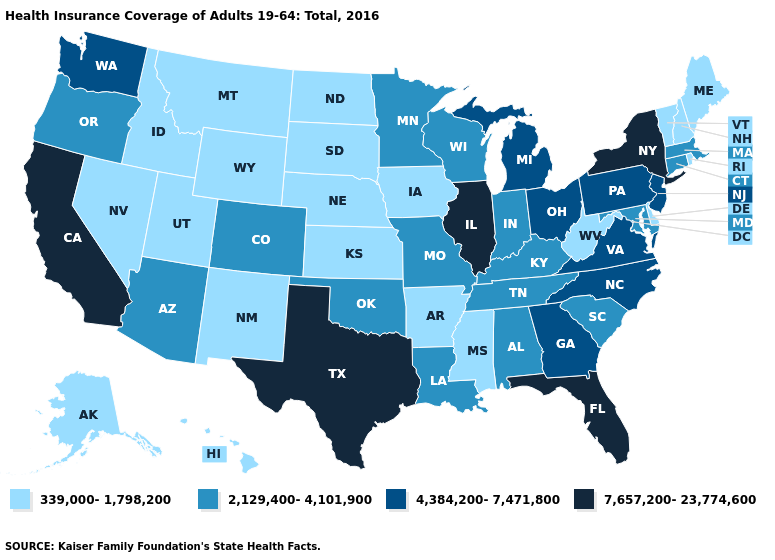Does Alabama have the same value as New Hampshire?
Be succinct. No. Name the states that have a value in the range 7,657,200-23,774,600?
Keep it brief. California, Florida, Illinois, New York, Texas. Name the states that have a value in the range 2,129,400-4,101,900?
Be succinct. Alabama, Arizona, Colorado, Connecticut, Indiana, Kentucky, Louisiana, Maryland, Massachusetts, Minnesota, Missouri, Oklahoma, Oregon, South Carolina, Tennessee, Wisconsin. What is the value of Illinois?
Answer briefly. 7,657,200-23,774,600. Does California have the same value as Texas?
Write a very short answer. Yes. Which states have the highest value in the USA?
Answer briefly. California, Florida, Illinois, New York, Texas. What is the value of Virginia?
Be succinct. 4,384,200-7,471,800. Does the first symbol in the legend represent the smallest category?
Give a very brief answer. Yes. What is the value of Maryland?
Give a very brief answer. 2,129,400-4,101,900. Which states have the lowest value in the USA?
Write a very short answer. Alaska, Arkansas, Delaware, Hawaii, Idaho, Iowa, Kansas, Maine, Mississippi, Montana, Nebraska, Nevada, New Hampshire, New Mexico, North Dakota, Rhode Island, South Dakota, Utah, Vermont, West Virginia, Wyoming. Does the map have missing data?
Concise answer only. No. Name the states that have a value in the range 2,129,400-4,101,900?
Keep it brief. Alabama, Arizona, Colorado, Connecticut, Indiana, Kentucky, Louisiana, Maryland, Massachusetts, Minnesota, Missouri, Oklahoma, Oregon, South Carolina, Tennessee, Wisconsin. What is the value of New Hampshire?
Keep it brief. 339,000-1,798,200. What is the value of New Jersey?
Quick response, please. 4,384,200-7,471,800. Is the legend a continuous bar?
Concise answer only. No. 